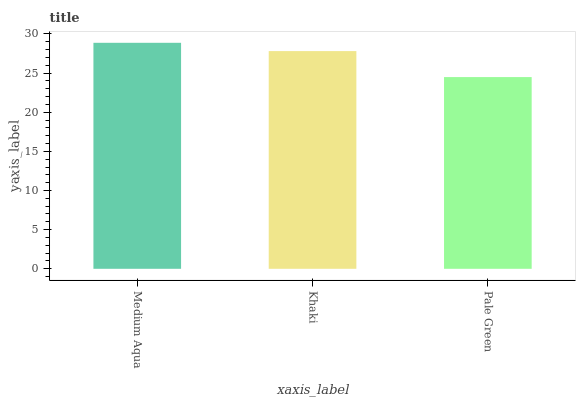Is Pale Green the minimum?
Answer yes or no. Yes. Is Medium Aqua the maximum?
Answer yes or no. Yes. Is Khaki the minimum?
Answer yes or no. No. Is Khaki the maximum?
Answer yes or no. No. Is Medium Aqua greater than Khaki?
Answer yes or no. Yes. Is Khaki less than Medium Aqua?
Answer yes or no. Yes. Is Khaki greater than Medium Aqua?
Answer yes or no. No. Is Medium Aqua less than Khaki?
Answer yes or no. No. Is Khaki the high median?
Answer yes or no. Yes. Is Khaki the low median?
Answer yes or no. Yes. Is Medium Aqua the high median?
Answer yes or no. No. Is Pale Green the low median?
Answer yes or no. No. 